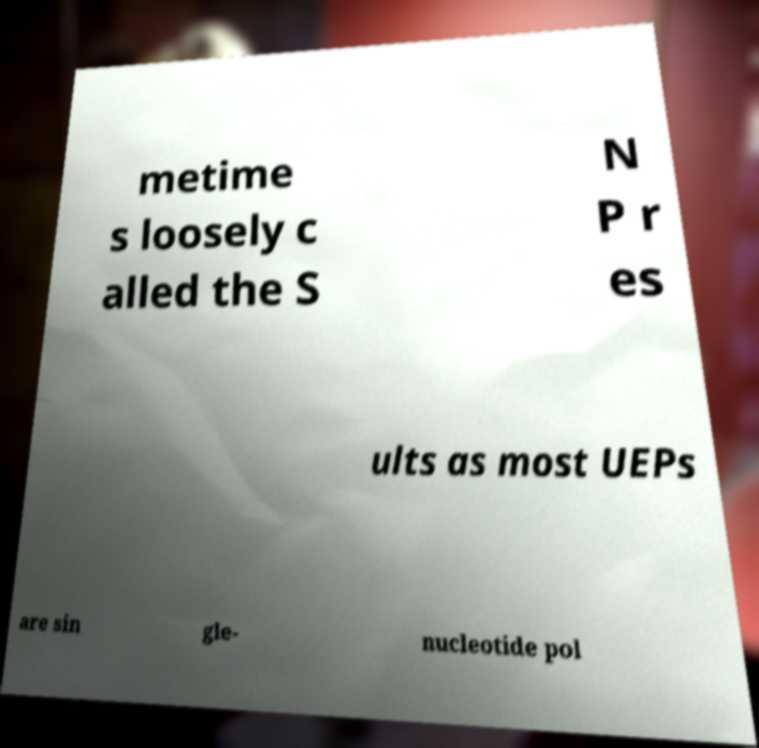Please identify and transcribe the text found in this image. metime s loosely c alled the S N P r es ults as most UEPs are sin gle- nucleotide pol 